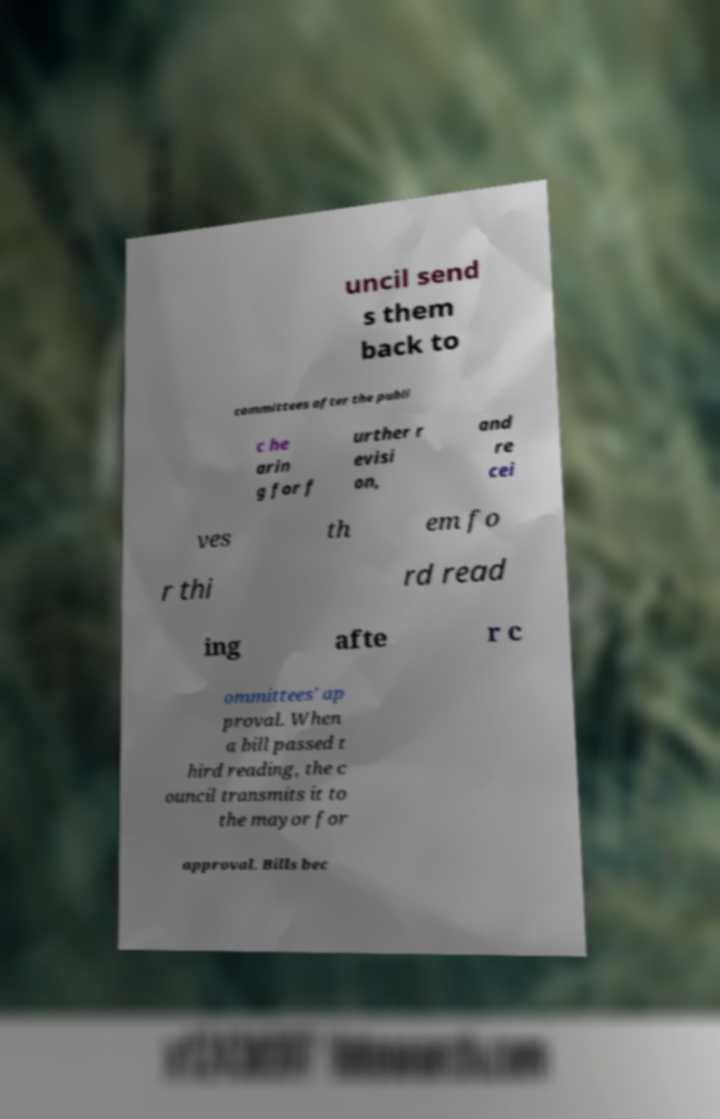Could you assist in decoding the text presented in this image and type it out clearly? uncil send s them back to committees after the publi c he arin g for f urther r evisi on, and re cei ves th em fo r thi rd read ing afte r c ommittees' ap proval. When a bill passed t hird reading, the c ouncil transmits it to the mayor for approval. Bills bec 